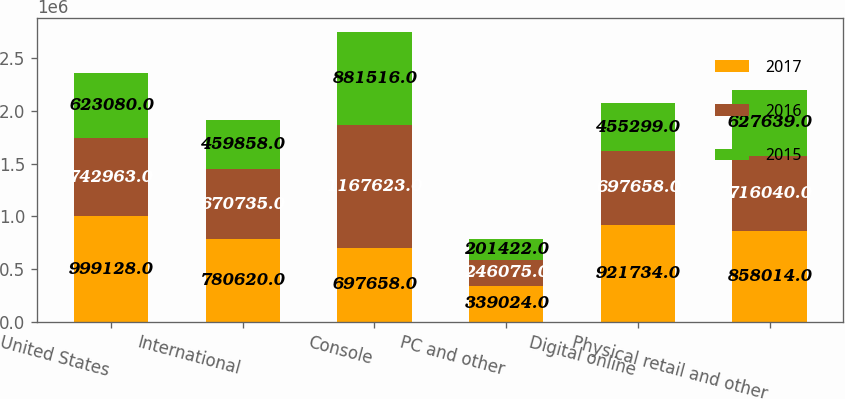Convert chart to OTSL. <chart><loc_0><loc_0><loc_500><loc_500><stacked_bar_chart><ecel><fcel>United States<fcel>International<fcel>Console<fcel>PC and other<fcel>Digital online<fcel>Physical retail and other<nl><fcel>2017<fcel>999128<fcel>780620<fcel>697658<fcel>339024<fcel>921734<fcel>858014<nl><fcel>2016<fcel>742963<fcel>670735<fcel>1.16762e+06<fcel>246075<fcel>697658<fcel>716040<nl><fcel>2015<fcel>623080<fcel>459858<fcel>881516<fcel>201422<fcel>455299<fcel>627639<nl></chart> 